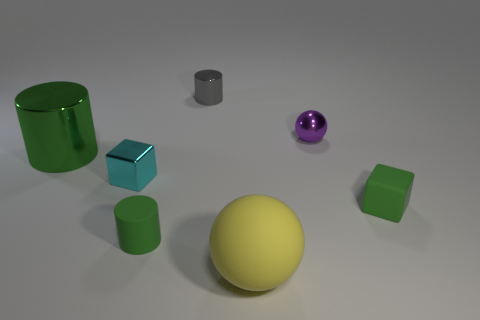Add 2 gray blocks. How many objects exist? 9 Subtract all small gray metallic cylinders. How many cylinders are left? 2 Subtract all green cylinders. How many cylinders are left? 1 Subtract all cubes. How many objects are left? 5 Subtract all big balls. Subtract all yellow metallic cylinders. How many objects are left? 6 Add 4 green objects. How many green objects are left? 7 Add 2 small rubber cylinders. How many small rubber cylinders exist? 3 Subtract 0 purple cylinders. How many objects are left? 7 Subtract 3 cylinders. How many cylinders are left? 0 Subtract all cyan cubes. Subtract all brown cylinders. How many cubes are left? 1 